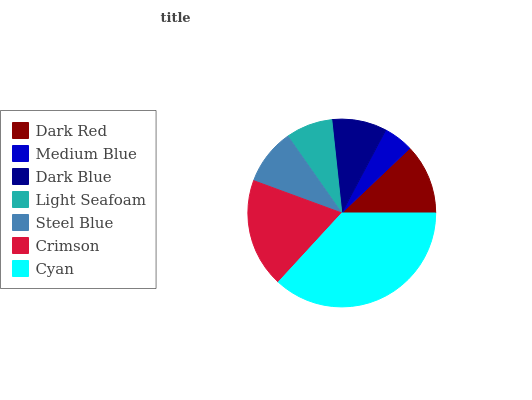Is Medium Blue the minimum?
Answer yes or no. Yes. Is Cyan the maximum?
Answer yes or no. Yes. Is Dark Blue the minimum?
Answer yes or no. No. Is Dark Blue the maximum?
Answer yes or no. No. Is Dark Blue greater than Medium Blue?
Answer yes or no. Yes. Is Medium Blue less than Dark Blue?
Answer yes or no. Yes. Is Medium Blue greater than Dark Blue?
Answer yes or no. No. Is Dark Blue less than Medium Blue?
Answer yes or no. No. Is Steel Blue the high median?
Answer yes or no. Yes. Is Steel Blue the low median?
Answer yes or no. Yes. Is Dark Blue the high median?
Answer yes or no. No. Is Crimson the low median?
Answer yes or no. No. 